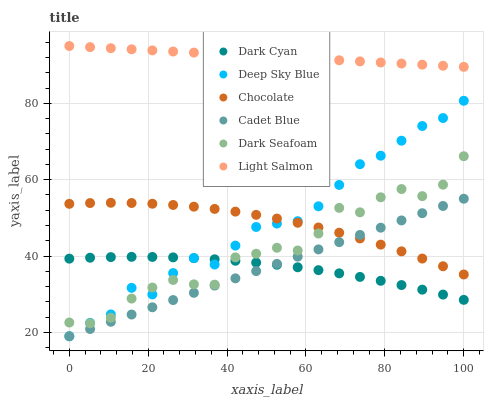Does Dark Cyan have the minimum area under the curve?
Answer yes or no. Yes. Does Light Salmon have the maximum area under the curve?
Answer yes or no. Yes. Does Cadet Blue have the minimum area under the curve?
Answer yes or no. No. Does Cadet Blue have the maximum area under the curve?
Answer yes or no. No. Is Cadet Blue the smoothest?
Answer yes or no. Yes. Is Dark Seafoam the roughest?
Answer yes or no. Yes. Is Chocolate the smoothest?
Answer yes or no. No. Is Chocolate the roughest?
Answer yes or no. No. Does Cadet Blue have the lowest value?
Answer yes or no. Yes. Does Chocolate have the lowest value?
Answer yes or no. No. Does Light Salmon have the highest value?
Answer yes or no. Yes. Does Cadet Blue have the highest value?
Answer yes or no. No. Is Chocolate less than Light Salmon?
Answer yes or no. Yes. Is Light Salmon greater than Cadet Blue?
Answer yes or no. Yes. Does Dark Cyan intersect Cadet Blue?
Answer yes or no. Yes. Is Dark Cyan less than Cadet Blue?
Answer yes or no. No. Is Dark Cyan greater than Cadet Blue?
Answer yes or no. No. Does Chocolate intersect Light Salmon?
Answer yes or no. No. 